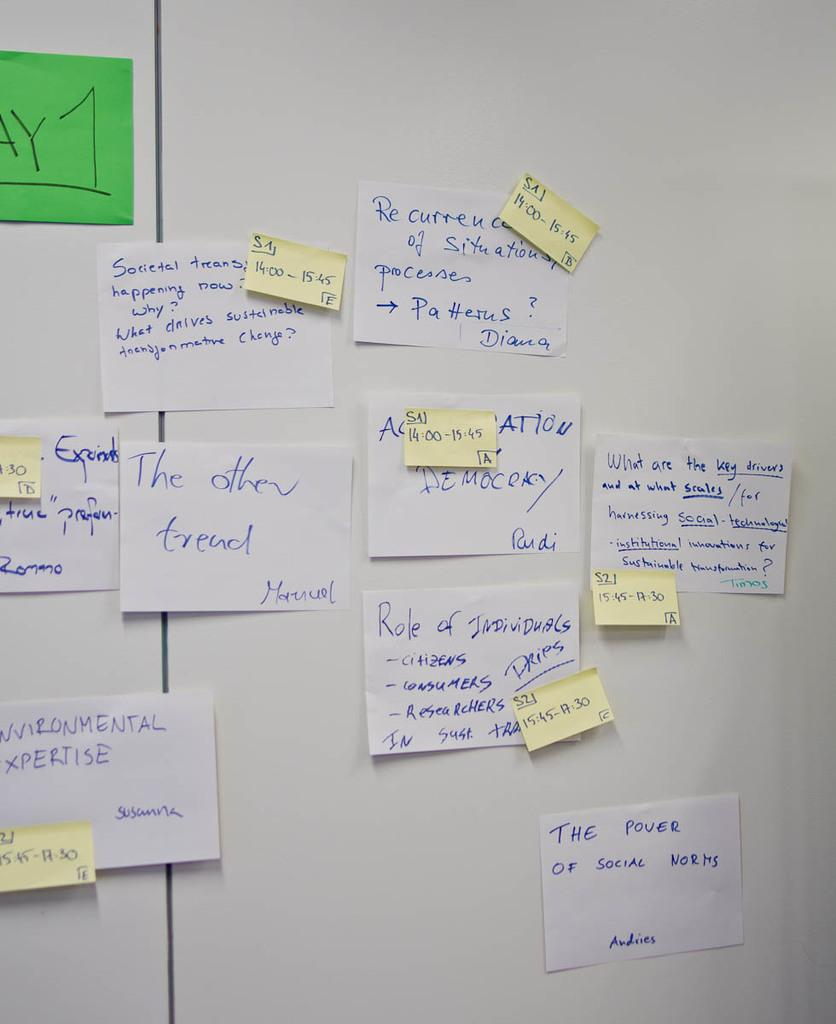<image>
Render a clear and concise summary of the photo. White wall of post it notes showing people's names and their tasks. 